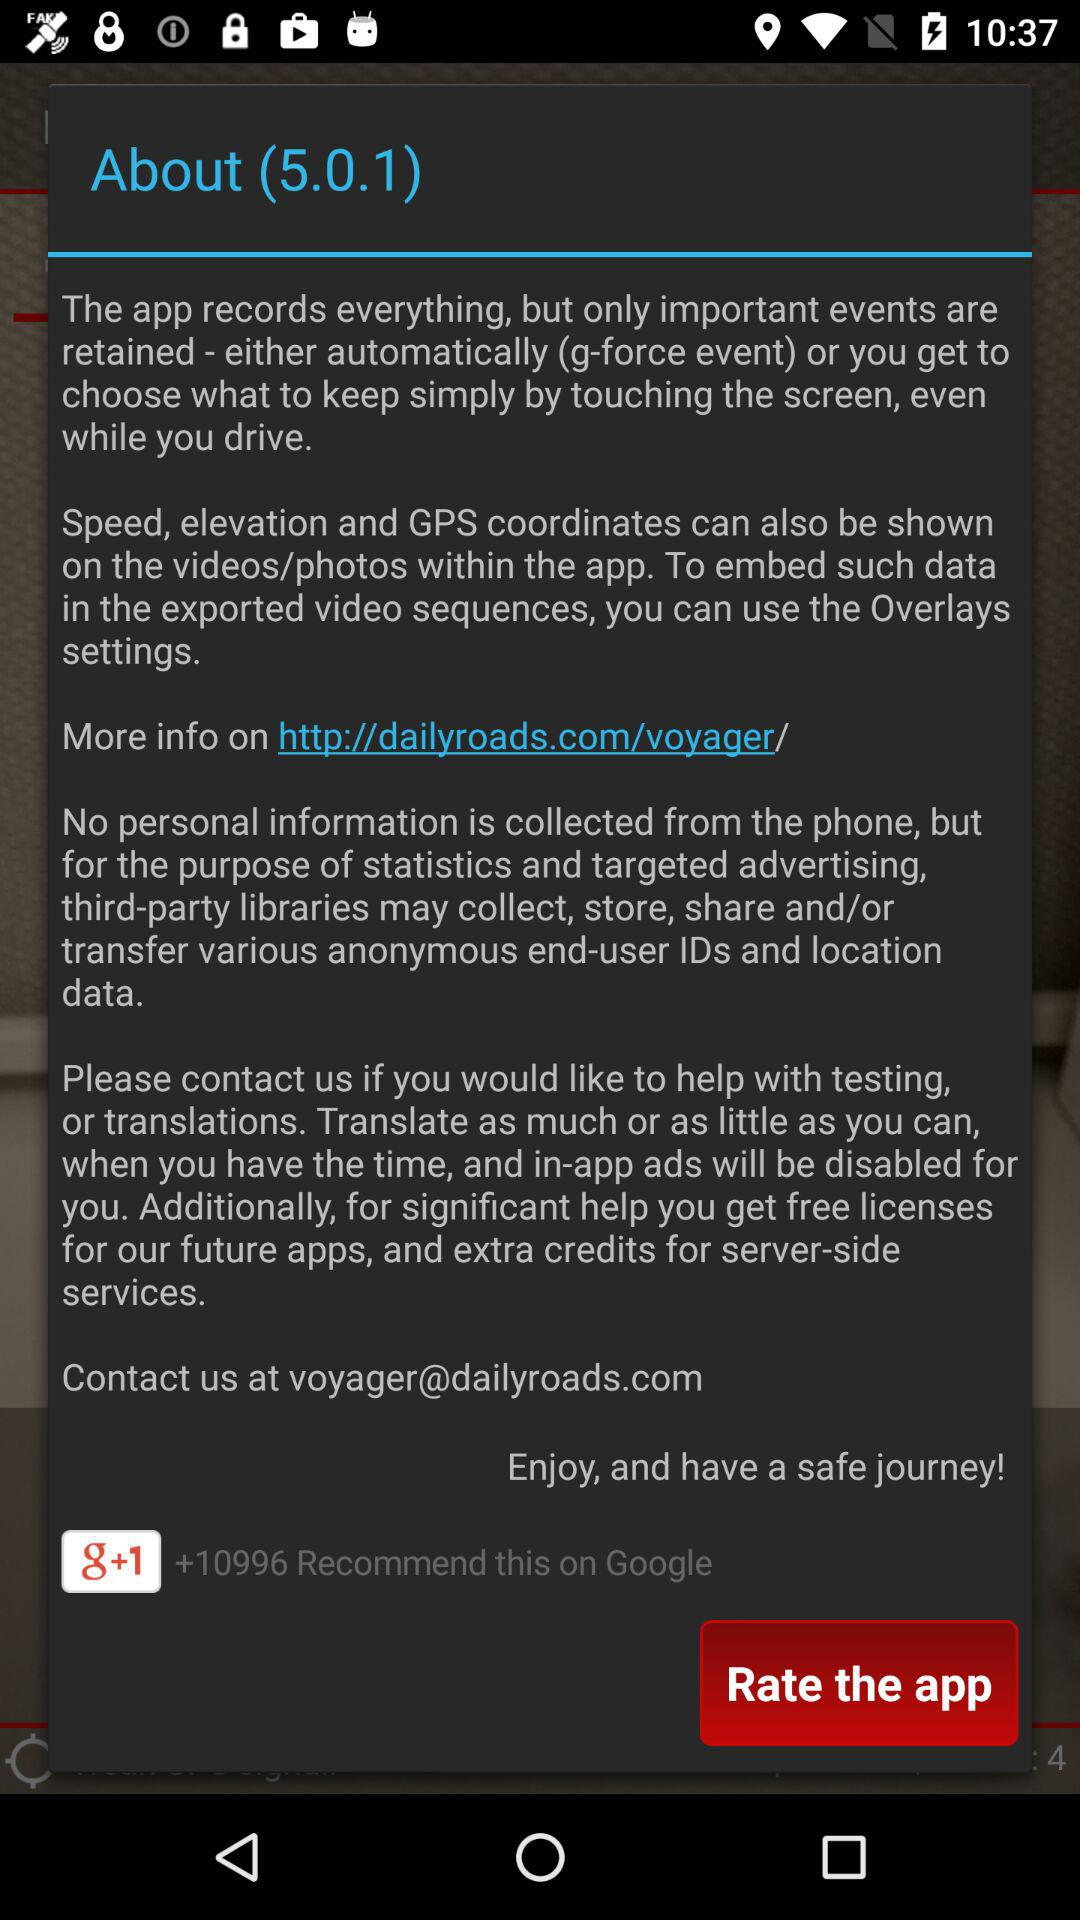What is the contact email address? The contact email address is voyager@dailyroads.com. 